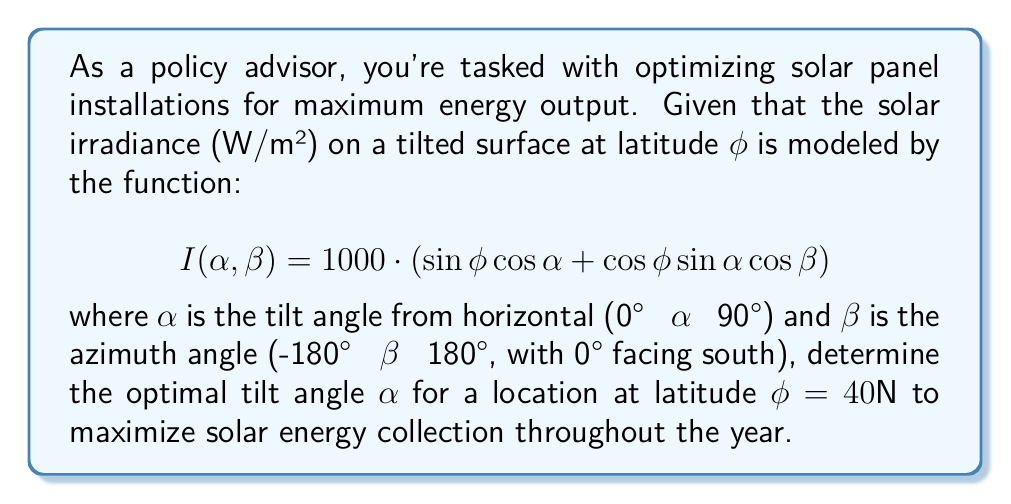Help me with this question. To find the optimal tilt angle, we need to maximize the solar irradiance function $I(\alpha, \beta)$ with respect to $\alpha$. Since we're interested in year-round performance, we'll consider the average case where $\beta = 0°$ (facing south).

1. Simplify the function for $\phi = 40°$ and $\beta = 0°$:
   $$I(\alpha) = 1000 \cdot (\sin 40° \cos\alpha + \cos 40° \sin\alpha)$$

2. To find the maximum, we need to find where the derivative $\frac{dI}{d\alpha} = 0$:
   $$\frac{dI}{d\alpha} = 1000 \cdot (-\sin 40° \sin\alpha + \cos 40° \cos\alpha)$$

3. Set the derivative to zero and solve:
   $$-\sin 40° \sin\alpha + \cos 40° \cos\alpha = 0$$
   $$\tan\alpha = \frac{\cos 40°}{\sin 40°} = \cot 40°$$

4. Taking the inverse tangent of both sides:
   $$\alpha = \arctan(\cot 40°)$$

5. Simplify:
   $$\alpha = 90° - 40° = 50°$$

6. Verify this is a maximum by checking the second derivative is negative at $\alpha = 50°$.

[asy]
import graph;
size(200,200);
real f(real x) {return 1000*(sind(40)*cosd(x) + cosd(40)*sind(x));}
draw(graph(f,0,90));
dot((50,f(50)));
label("Maximum",((50,f(50))),NE);
xaxis("Tilt Angle (α)",0,90,Arrow);
yaxis("Solar Irradiance (W/m²)",0,1000,Arrow);
label("I(α)",((80,f(80))),E);
[/asy]

The graph confirms that 50° is indeed the maximum point for the function.
Answer: $50°$ 